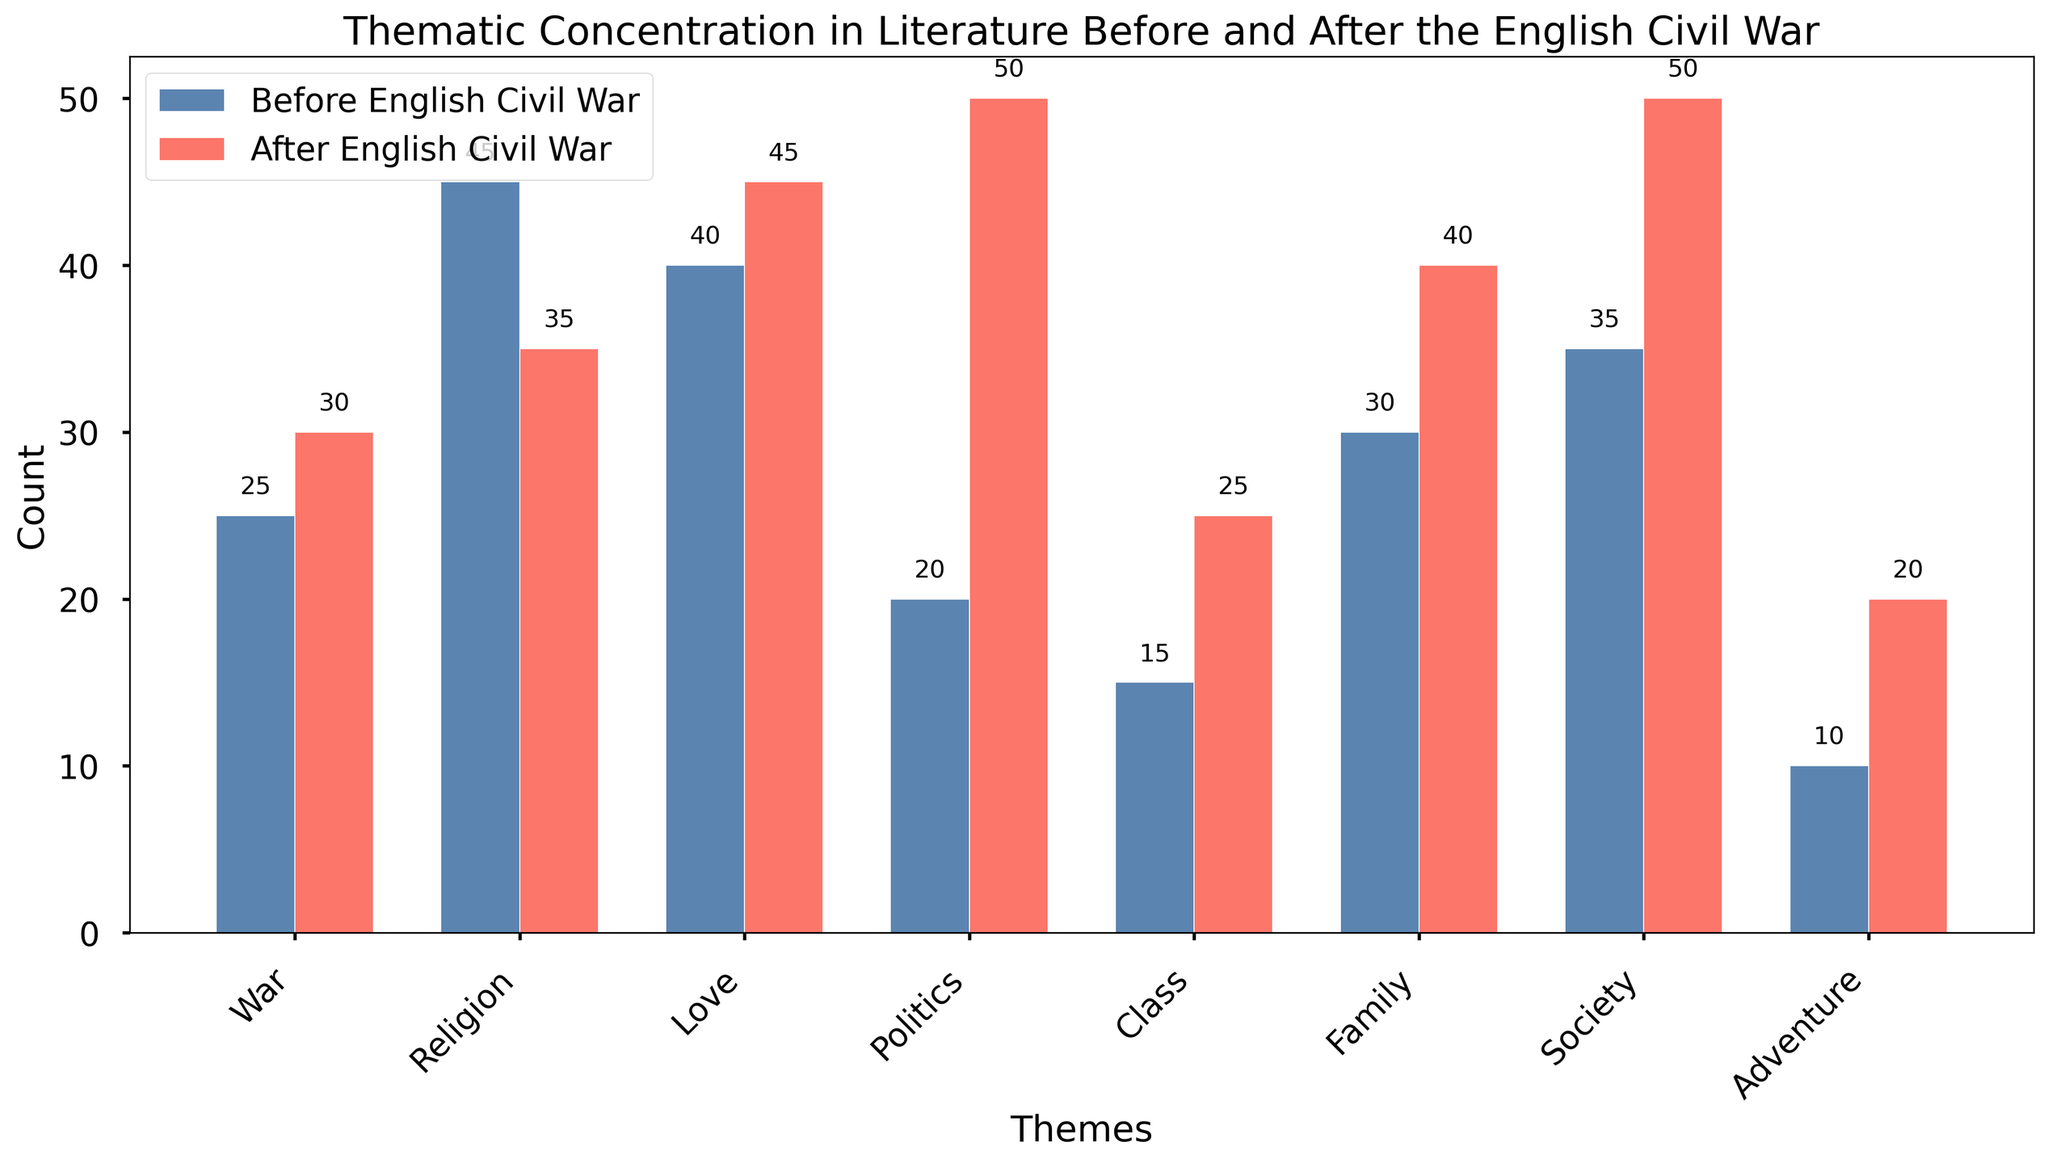What theme saw the greatest increase in count after the English Civil War compared to before? To determine which theme saw the greatest increase, calculate the difference in counts before and after the English Civil War for each theme. The differences are: War (+5), Religion (-10), Love (+5), Politics (+30), Class (+10), Family (+10), Society (+15), and Adventure (+10). The greatest increase is in Politics, with +30.
Answer: Politics Which theme had a higher count before the English Civil War than after? Compare counts for each theme before and after the English Civil War. Religion is the only theme with a higher count before (45) than after (35).
Answer: Religion After the English Civil War, which theme had the highest count? Review the counts of each theme after the English Civil War. The highest count is for Society, with 50.
Answer: Society How many themes have an equal or increased count after the English Civil War compared to before? Count the number of themes where the after count is equal to or greater than the before count. All themes except Religion have an equal or increased count. Therefore, there are 7 such themes.
Answer: 7 What is the average count of themes before the English Civil War? Sum the counts of all themes before the English Civil War and then divide by the number of themes. The sums are: 25 (War) + 45 (Religion) + 40 (Love) + 20 (Politics) + 15 (Class) + 30 (Family) + 35 (Society) + 10 (Adventure) = 220. The average is 220/8 = 27.5.
Answer: 27.5 Which theme had the smallest count before the English Civil War? Look for the theme with the smallest count before the English Civil War. Adventure had the smallest count with 10.
Answer: Adventure What is the combined count for the theme of Family, both before and after the English Civil War? Add the counts of Family before (30) and after (40) the English Civil War. The combined count is 30 + 40 = 70.
Answer: 70 By how much did the count of the Politics theme change after the English Civil War compared to before? Calculate the difference in counts for Politics before (20) and after (50) the English Civil War. The change is 50 - 20 = 30.
Answer: 30 